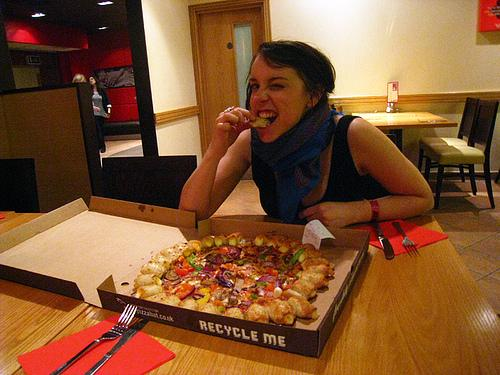Which item here can be turned into something else without eating it? box 